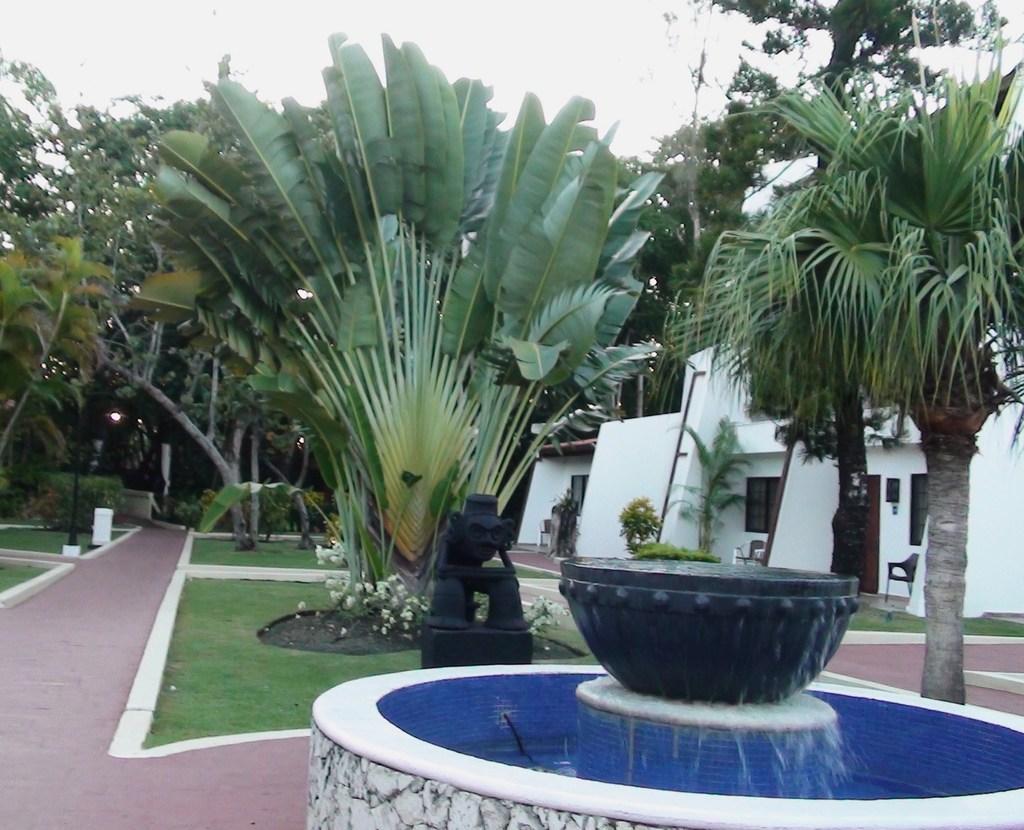Please provide a concise description of this image. There is a fountain. Here we can see grass, plants, trees, sculpture, chairs, water, and houses. In the background there is sky. 